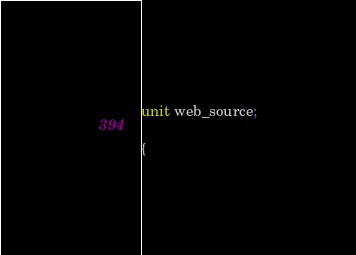<code> <loc_0><loc_0><loc_500><loc_500><_Pascal_>unit web_source;

{</code> 